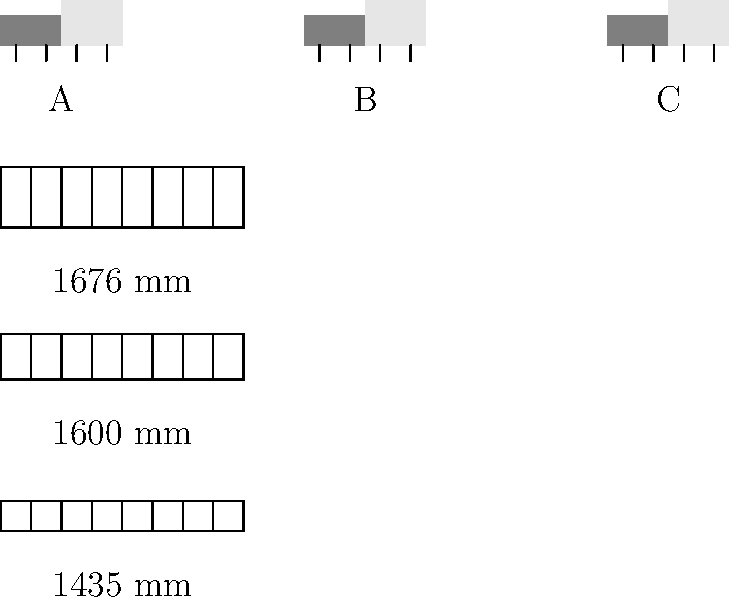Match the early locomotive types (A, B, C) to their corresponding train track gauges (1435 mm, 1600 mm, 1676 mm) based on their wheel alignments and sizes. Which combination is correct? To solve this question, we need to analyze the relationship between the locomotive wheel spacing and the track gauges:

1. Observe the wheel spacing of each locomotive:
   - Locomotive A has the narrowest wheel spacing
   - Locomotive B has a medium wheel spacing
   - Locomotive C has the widest wheel spacing

2. Compare the track gauges:
   - 1435 mm is the narrowest gauge
   - 1600 mm is the medium gauge
   - 1676 mm is the widest gauge

3. Match the locomotives to the track gauges:
   - Locomotive A's narrow wheel spacing matches the 1435 mm gauge
   - Locomotive B's medium wheel spacing matches the 1600 mm gauge
   - Locomotive C's wide wheel spacing matches the 1676 mm gauge

4. The correct combination is:
   A - 1435 mm
   B - 1600 mm
   C - 1676 mm

This matching reflects the historical development of rail gauges, where different regions and countries adopted various standards based on their specific needs and engineering preferences.
Answer: A-1435 mm, B-1600 mm, C-1676 mm 